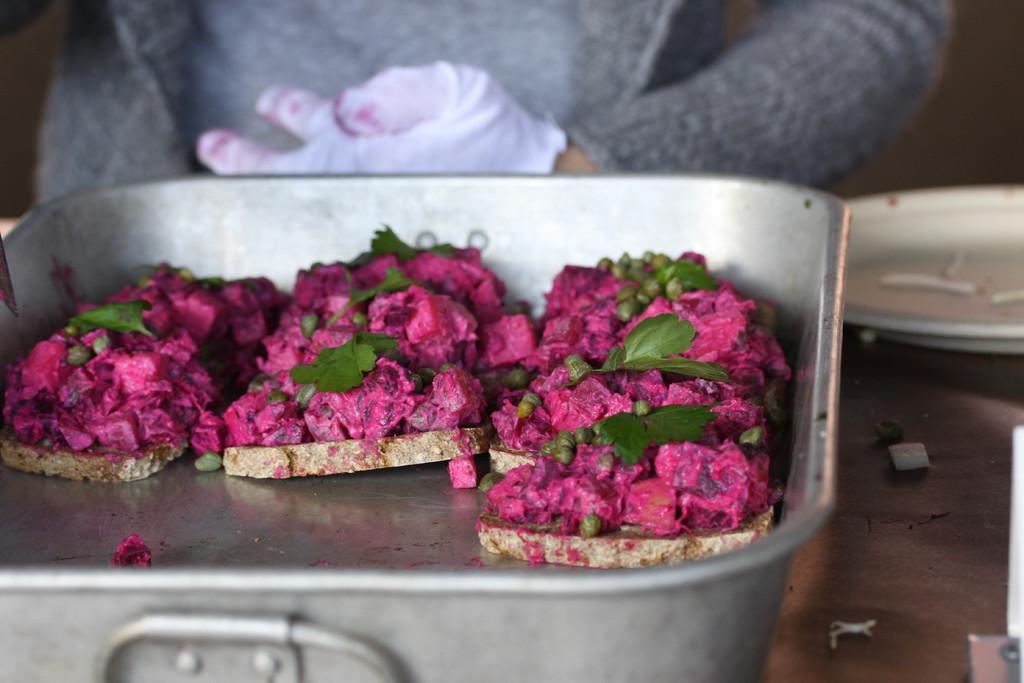Can you describe this image briefly? In this image in the front there is food. In the background there is a person and on the right side there are objects which are visible. 